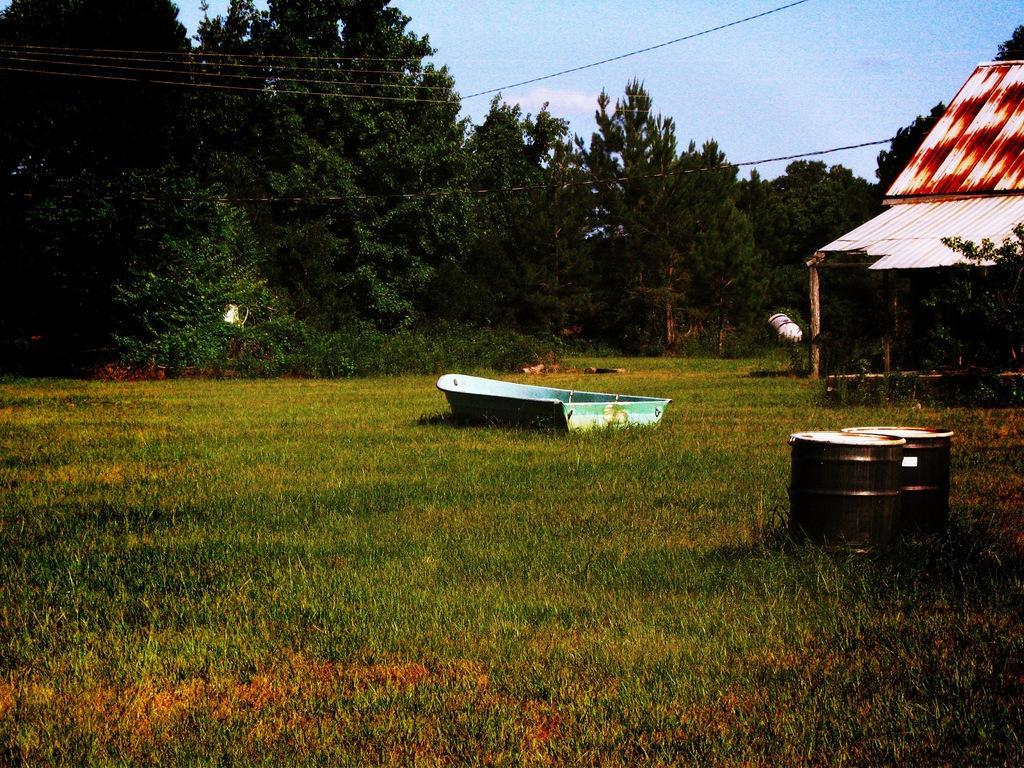In one or two sentences, can you explain what this image depicts? In the image there is a ship on the grass land with two drums on the right side with a shed behind it, there are plants and trees in the background all over the image and above its sky. 